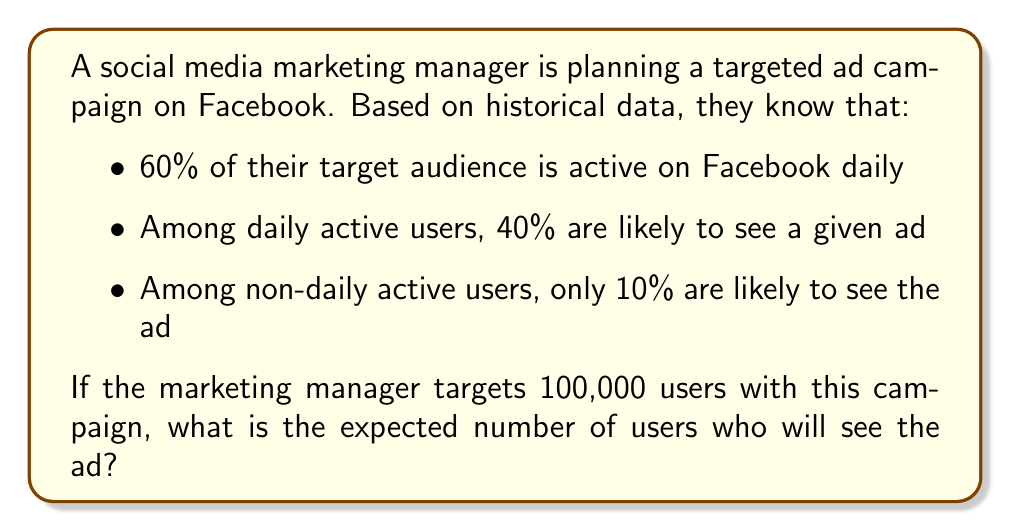Help me with this question. Let's approach this step-by-step using conditional probability:

1) Define events:
   A: User is active daily
   S: User sees the ad

2) Given probabilities:
   $P(A) = 0.60$
   $P(S|A) = 0.40$
   $P(S|not A) = 0.10$

3) We need to find $P(S)$, the probability that a user sees the ad. We can use the law of total probability:

   $P(S) = P(S|A) \cdot P(A) + P(S|not A) \cdot P(not A)$

4) Calculate $P(not A)$:
   $P(not A) = 1 - P(A) = 1 - 0.60 = 0.40$

5) Now, let's substitute the values into the formula:

   $P(S) = 0.40 \cdot 0.60 + 0.10 \cdot 0.40$

6) Calculate:
   $P(S) = 0.24 + 0.04 = 0.28$

7) The probability of a user seeing the ad is 0.28 or 28%.

8) For 100,000 targeted users, the expected number who will see the ad is:

   $100,000 \cdot 0.28 = 28,000$

Therefore, the expected number of users who will see the ad is 28,000.
Answer: 28,000 users 